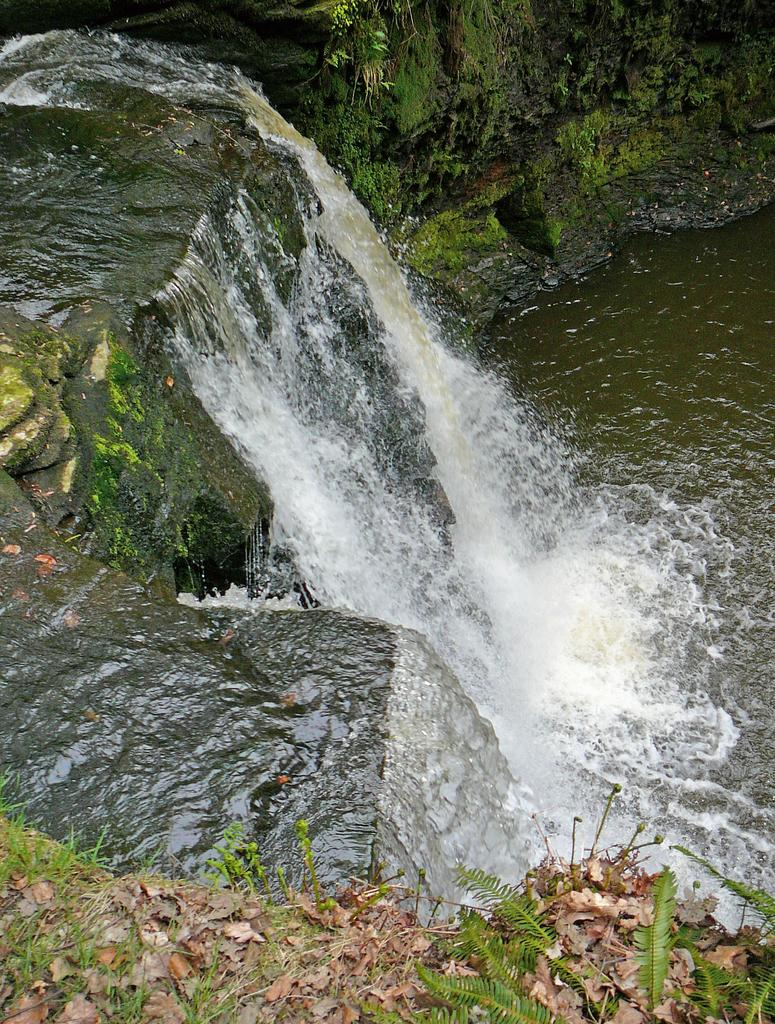What is happening in the image? There is water flowing in the image. Where is the water coming from? The water is flowing from a mountain. What else can be seen in the image? There are dried leaves in the image. How many fish can be seen swimming in the water in the image? There are no fish visible in the image; it only shows water flowing from a mountain and dried leaves. 